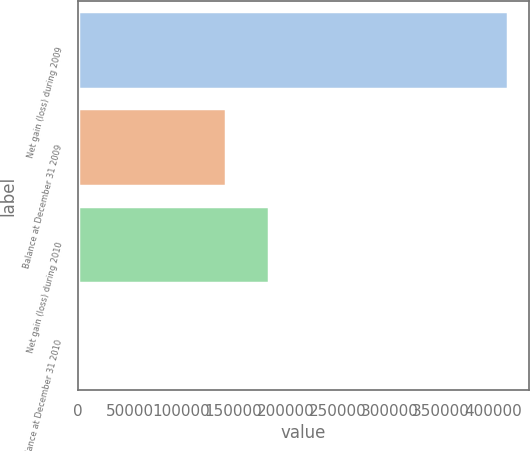Convert chart. <chart><loc_0><loc_0><loc_500><loc_500><bar_chart><fcel>Net gain (loss) during 2009<fcel>Balance at December 31 2009<fcel>Net gain (loss) during 2010<fcel>Balance at December 31 2010<nl><fcel>413815<fcel>142853<fcel>184001<fcel>2332<nl></chart> 